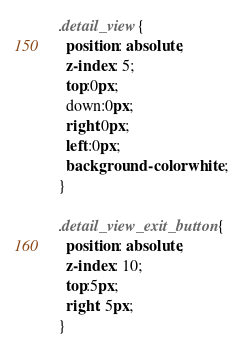<code> <loc_0><loc_0><loc_500><loc_500><_CSS_>.detail_view{
  position: absolute;
  z-index: 5;
  top:0px;
  down:0px;
  right:0px;
  left:0px;
  background-color: white;
}

.detail_view_exit_button{
  position: absolute;
  z-index: 10;
  top:5px;
  right: 5px;
}
</code> 